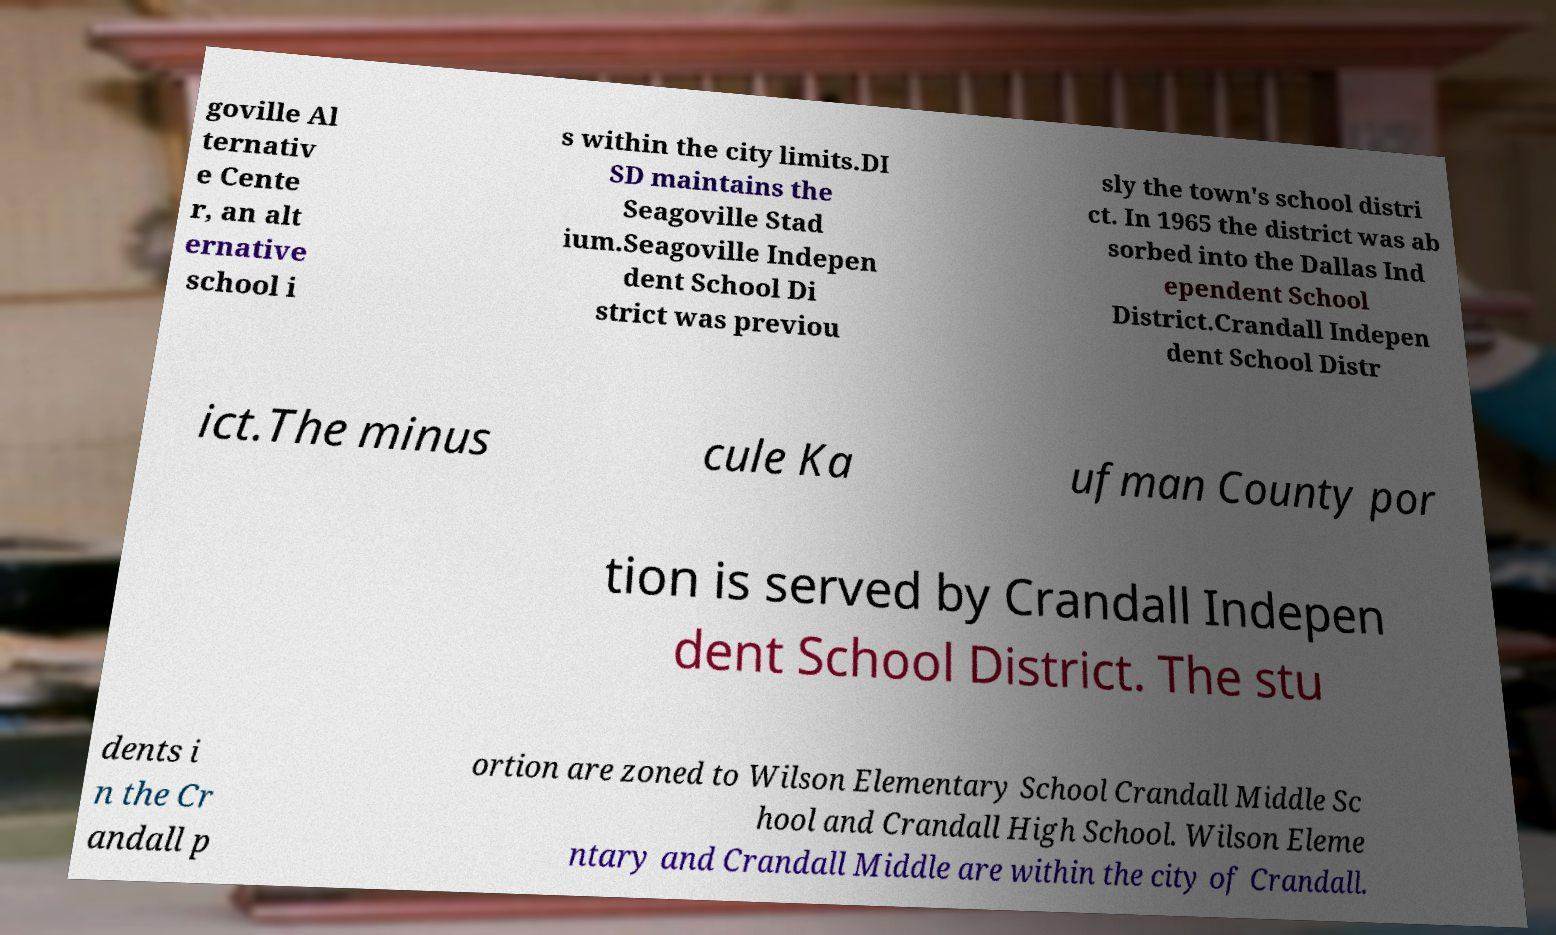I need the written content from this picture converted into text. Can you do that? goville Al ternativ e Cente r, an alt ernative school i s within the city limits.DI SD maintains the Seagoville Stad ium.Seagoville Indepen dent School Di strict was previou sly the town's school distri ct. In 1965 the district was ab sorbed into the Dallas Ind ependent School District.Crandall Indepen dent School Distr ict.The minus cule Ka ufman County por tion is served by Crandall Indepen dent School District. The stu dents i n the Cr andall p ortion are zoned to Wilson Elementary School Crandall Middle Sc hool and Crandall High School. Wilson Eleme ntary and Crandall Middle are within the city of Crandall. 